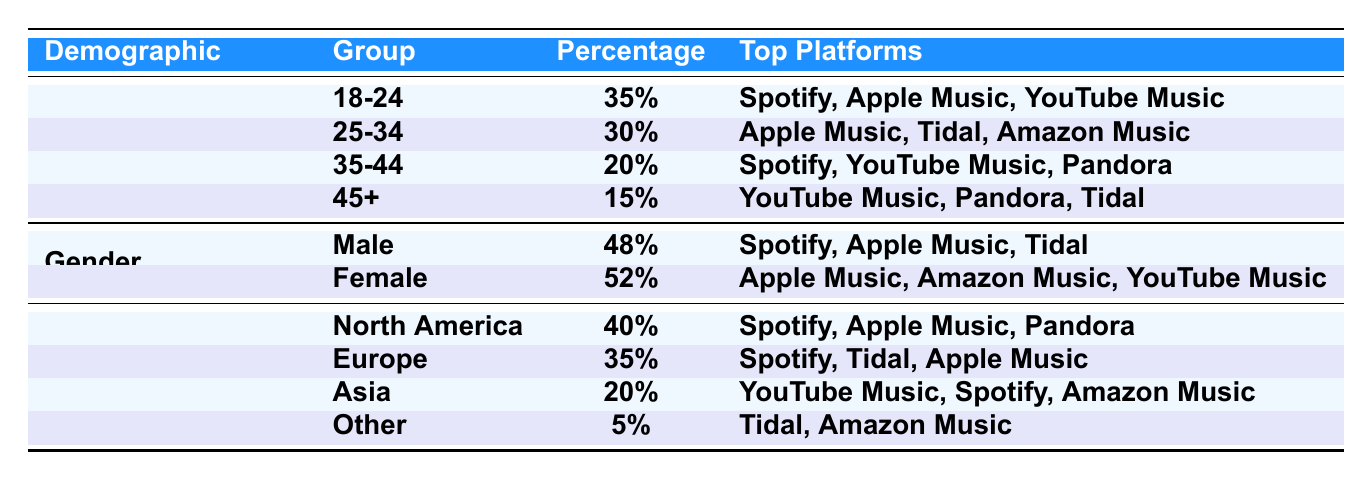What percentage of subscribers are aged 18-24? According to the table, the age group 18-24 has a percentage listed as 35%.
Answer: 35% What are the top platforms for the 35-44 age group? The table shows that the top platforms for the 35-44 age group are Spotify, YouTube Music, and Pandora.
Answer: Spotify, YouTube Music, Pandora Which gender has a higher subscriber percentage? The table indicates that Female subscribers make up 52%, while Male subscribers are at 48%. Thus, Female has the higher percentage.
Answer: Female What percentage of subscribers are from Asia? The Asia demographic shows a percentage of 20%.
Answer: 20% If we combine the percentages of the age groups 25-34 and 35-44, what do we get? The age group 25-34 has 30%, and the 35-44 group has 20%. Summing these values gives 30% + 20% = 50%.
Answer: 50% Which demographic has the least percentage of subscribers? The "Other" geographic region has the lowest subscriber percentage at 5%.
Answer: Other Do more subscribers prefer Spotify or YouTube Music? The table shows that Spotify is preferred by higher demographics, while YouTube Music is mentioned for age groups like 18-24 and 45+, indicating Spotify has a larger user base overall.
Answer: Yes, more prefer Spotify What is the combined percentage of male and female subscribers? The percentage of Male is 48% and Female is 52%. Adding these together gives 48% + 52% = 100%.
Answer: 100% In which geographic region is the highest percentage of subscribers found? North America has the highest percentage listed at 40%.
Answer: North America What percentage of subscribers is found in the 45+ age group, and how does it compare to the 18-24 age group? The 45+ age group has 15%, and the 18-24 age group has 35%. Therefore, 35% - 15% = 20% higher for the younger group.
Answer: 20% higher 